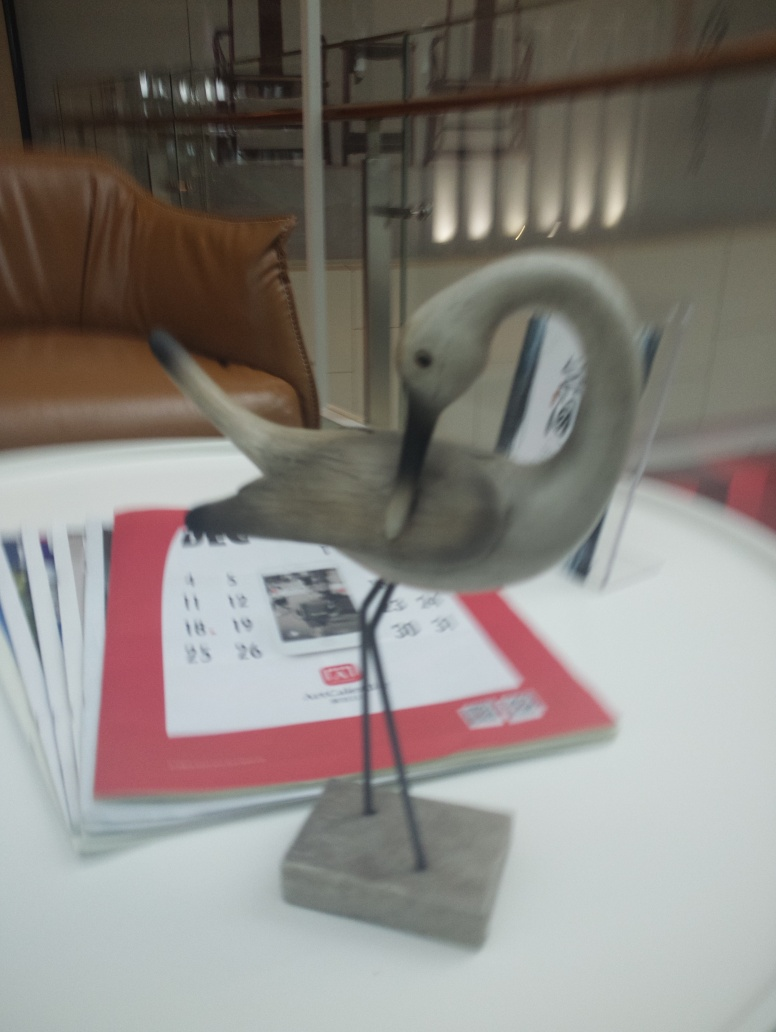Is the object intended to be functional or purely decorative? While it's not entirely clear without more context, the object seems to be primarily decorative. Its design and placement on a table, as well as how it is positioned—prominently and without any apparent practical use—suggest that its primary role is to be an aesthetic or symbolic element in the space. 